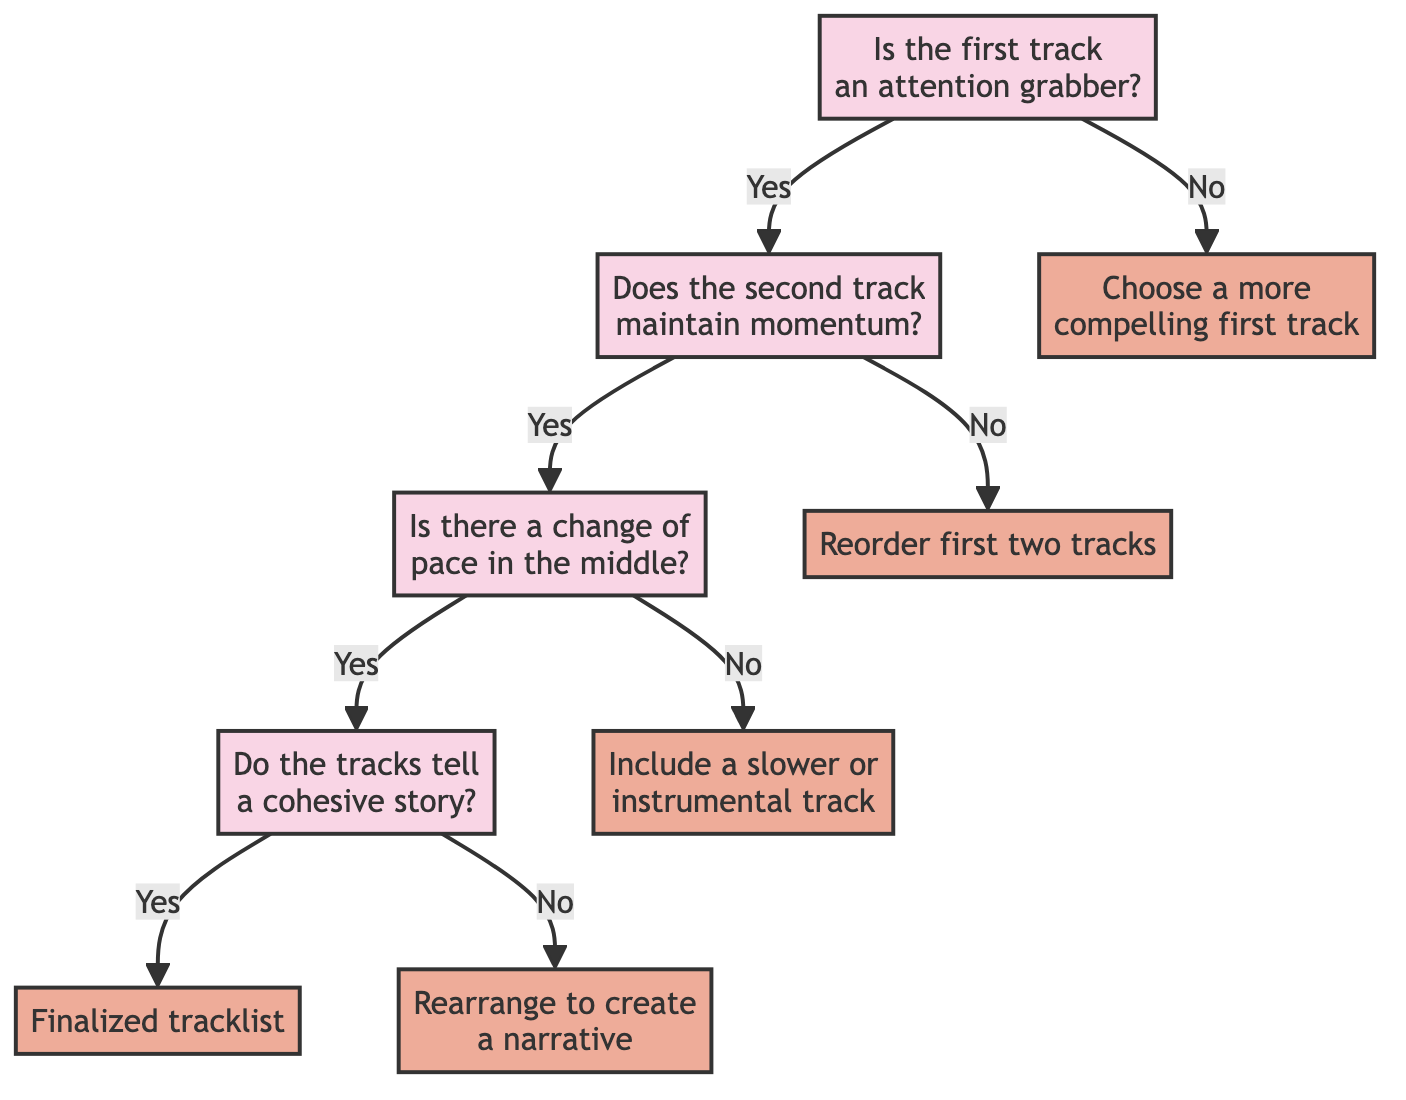What is the first question in the diagram? The first question in the diagram is located at the top node, asking whether the first track is an attention grabber.
Answer: Is the first track an attention grabber? What happens if the answer to the first question is 'no'? If the answer to the first question is 'no', the diagram indicates the next action, which is to choose a more compelling first track.
Answer: Choose a more compelling first track How many total decisions are present in the diagram? The diagram contains a total of six decisions represented by nodes leading to different outcomes based on the answers provided.
Answer: Six What is the consequence if the second track does not maintain momentum? If the second track does not maintain momentum, the diagram leads to the decision to reorder the first two tracks.
Answer: Reorder first two tracks What must be true for the final output to be a finalized tracklist? For the final output to be a finalized tracklist, both the second track must maintain momentum, and the tracks must tell a cohesive story in the end.
Answer: Finalized tracklist If there is a change of pace in the middle, what must be checked next? If there is a change of pace in the middle, the next question to be evaluated is whether the tracks tell a cohesive story.
Answer: Do the tracks tell a cohesive story? What are the two possible outcomes if the second track maintains momentum and there is no change of pace? If the second track maintains momentum and there is no change of pace, the outcome will be the inclusion of a slower or instrumental track as a response.
Answer: Include a slower or instrumental track If the tracks do not tell a cohesive story after a change of pace, what should be done? If after a change of pace the tracks do not tell a cohesive story, the action advised in the diagram is to rearrange the tracks to create a narrative.
Answer: Rearrange to create a narrative 